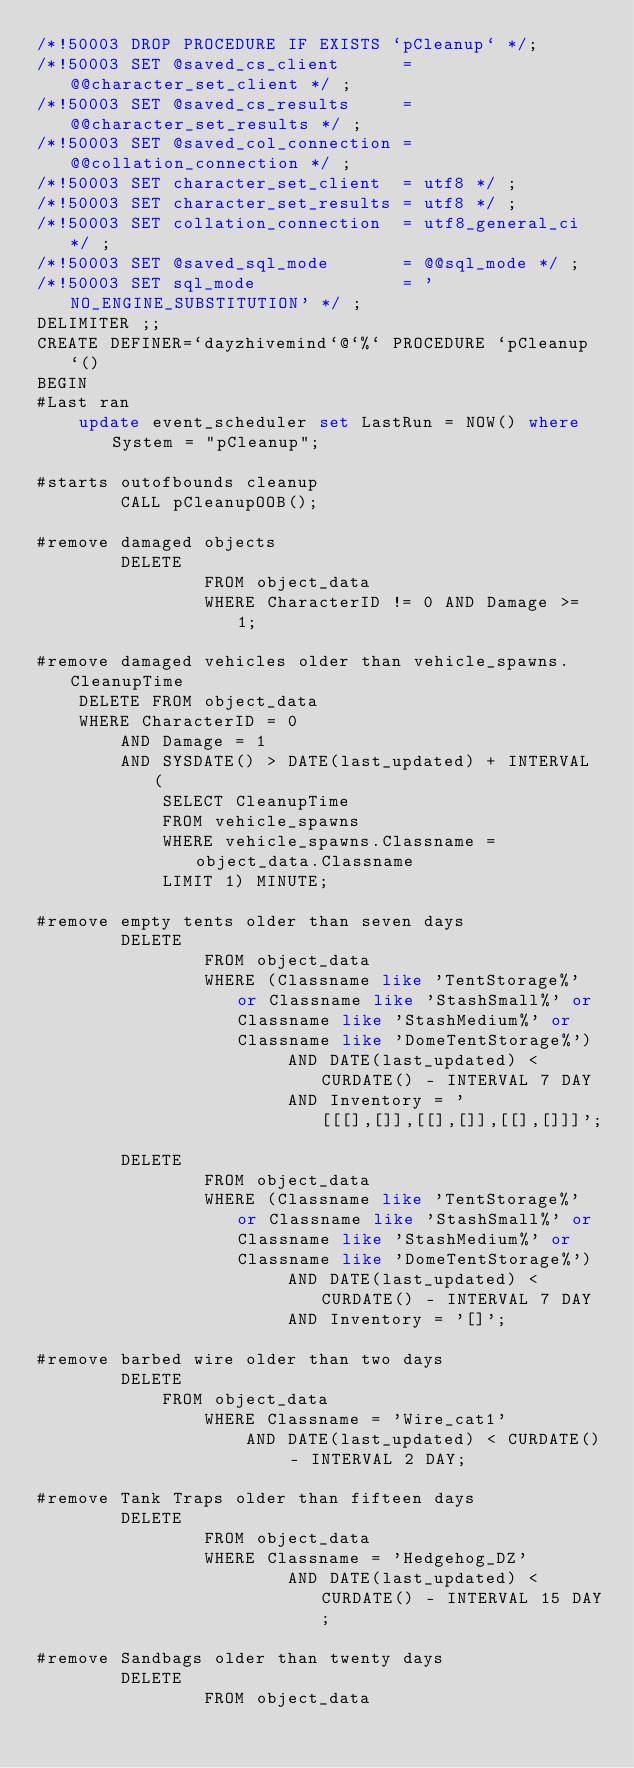Convert code to text. <code><loc_0><loc_0><loc_500><loc_500><_SQL_>/*!50003 DROP PROCEDURE IF EXISTS `pCleanup` */;
/*!50003 SET @saved_cs_client      = @@character_set_client */ ;
/*!50003 SET @saved_cs_results     = @@character_set_results */ ;
/*!50003 SET @saved_col_connection = @@collation_connection */ ;
/*!50003 SET character_set_client  = utf8 */ ;
/*!50003 SET character_set_results = utf8 */ ;
/*!50003 SET collation_connection  = utf8_general_ci */ ;
/*!50003 SET @saved_sql_mode       = @@sql_mode */ ;
/*!50003 SET sql_mode              = 'NO_ENGINE_SUBSTITUTION' */ ;
DELIMITER ;;
CREATE DEFINER=`dayzhivemind`@`%` PROCEDURE `pCleanup`()
BEGIN 
#Last ran
	update event_scheduler set LastRun = NOW() where System = "pCleanup";

#starts outofbounds cleanup
        CALL pCleanupOOB();
 
#remove damaged objects
        DELETE
                FROM object_data
                WHERE CharacterID != 0 AND Damage >= 1;

#remove damaged vehicles older than vehicle_spawns.CleanupTime
	DELETE FROM object_data
	WHERE CharacterID = 0
		AND Damage = 1
		AND SYSDATE() > DATE(last_updated) + INTERVAL (
			SELECT CleanupTime
			FROM vehicle_spawns
			WHERE vehicle_spawns.Classname = object_data.Classname
			LIMIT 1) MINUTE;

#remove empty tents older than seven days
        DELETE
                FROM object_data
                WHERE (Classname like 'TentStorage%' or Classname like 'StashSmall%' or Classname like 'StashMedium%' or Classname like 'DomeTentStorage%')
                        AND DATE(last_updated) < CURDATE() - INTERVAL 7 DAY
                        AND Inventory = '[[[],[]],[[],[]],[[],[]]]';
       
        DELETE
                FROM object_data
                WHERE (Classname like 'TentStorage%' or Classname like 'StashSmall%' or Classname like 'StashMedium%' or Classname like 'DomeTentStorage%')
                        AND DATE(last_updated) < CURDATE() - INTERVAL 7 DAY
                        AND Inventory = '[]';          
 
#remove barbed wire older than two days
        DELETE
            FROM object_data
				WHERE Classname = 'Wire_cat1'
					AND DATE(last_updated) < CURDATE() - INTERVAL 2 DAY;
					                      
#remove Tank Traps older than fifteen days
        DELETE
                FROM object_data
                WHERE Classname = 'Hedgehog_DZ'
                        AND DATE(last_updated) < CURDATE() - INTERVAL 15 DAY;
 
#remove Sandbags older than twenty days
        DELETE
                FROM object_data</code> 